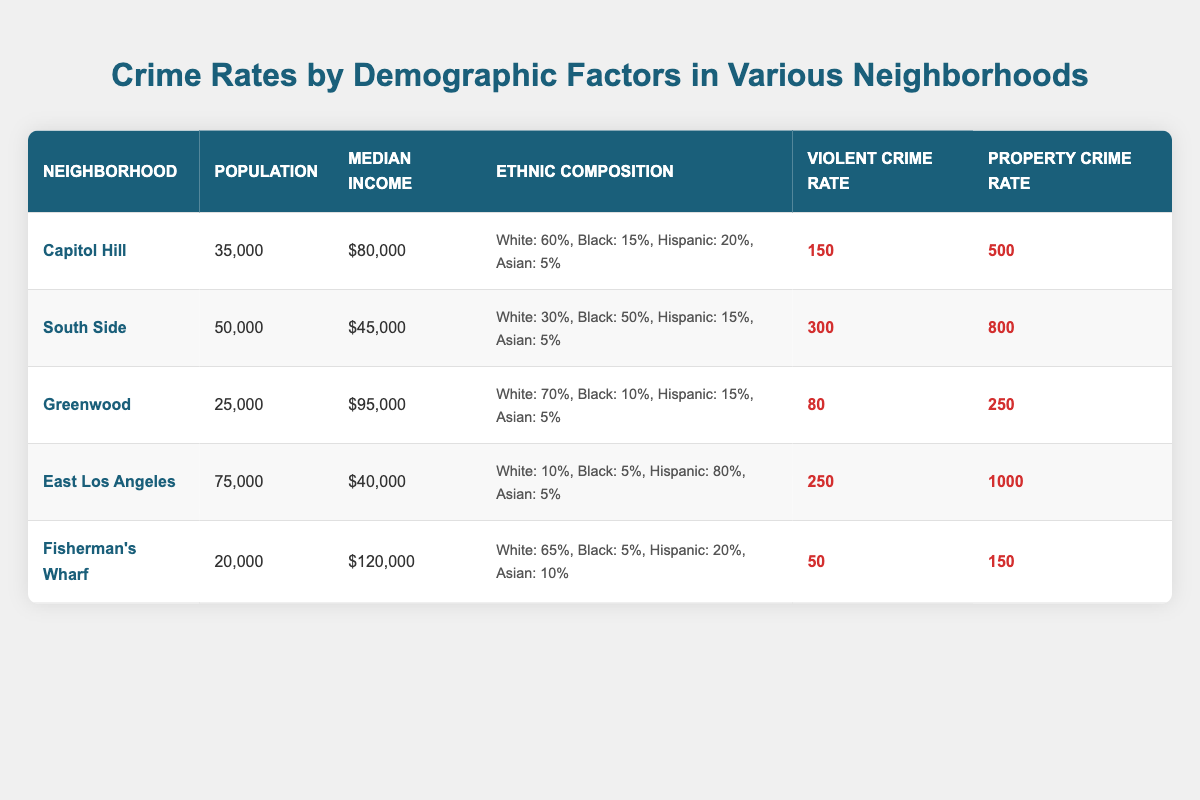What is the median income of the Capitol Hill neighborhood? The table indicates that the median income for Capitol Hill is listed as $80,000.
Answer: $80,000 Which neighborhood has the highest property crime rate? By reviewing the property crime rates, East Los Angeles has the highest rate at 1000.
Answer: East Los Angeles What is the total population of South Side and Greenwood combined? The total population is calculated by adding both populations: 50,000 (South Side) + 25,000 (Greenwood) = 75,000.
Answer: 75,000 Is the ethnic composition of Capitol Hill more predominantly white than Black? In Capitol Hill, the ethnic composition shows 60% White and 15% Black, confirming that White is the predominant ethnicity.
Answer: Yes What is the average violent crime rate across all neighborhoods? The average is found by summing all violent crime rates: 150 + 300 + 80 + 250 + 50 = 830, then dividing by 5 neighborhoods (830/5 = 166).
Answer: 166 Does Fisherman’s Wharf have a higher median income compared to South Side? Fisherman's Wharf has a median income of $120,000, while South Side has $45,000. This comparison shows that Fisherman's Wharf has a higher income.
Answer: Yes What is the difference in violent crime rate between East Los Angeles and Greenwood? The difference can be calculated by subtracting Greenwood's violent crime rate of 80 from East Los Angeles's rate of 250: 250 - 80 = 170.
Answer: 170 Which neighborhood has the lowest violent crime rate, and what is that rate? By examining the violent crime rates, the lowest rate is in Fisherman’s Wharf at 50.
Answer: Fisherman’s Wharf, 50 